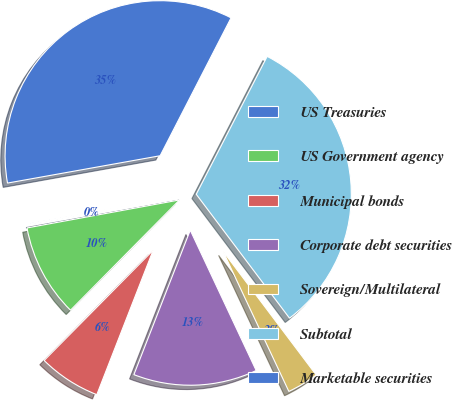Convert chart. <chart><loc_0><loc_0><loc_500><loc_500><pie_chart><fcel>US Treasuries<fcel>US Government agency<fcel>Municipal bonds<fcel>Corporate debt securities<fcel>Sovereign/Multilateral<fcel>Subtotal<fcel>Marketable securities<nl><fcel>0.07%<fcel>9.7%<fcel>6.49%<fcel>12.91%<fcel>3.28%<fcel>32.17%<fcel>35.38%<nl></chart> 